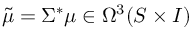Convert formula to latex. <formula><loc_0><loc_0><loc_500><loc_500>{ \tilde { \mu } } = \Sigma ^ { * } \mu \in \Omega ^ { 3 } ( S \times I )</formula> 